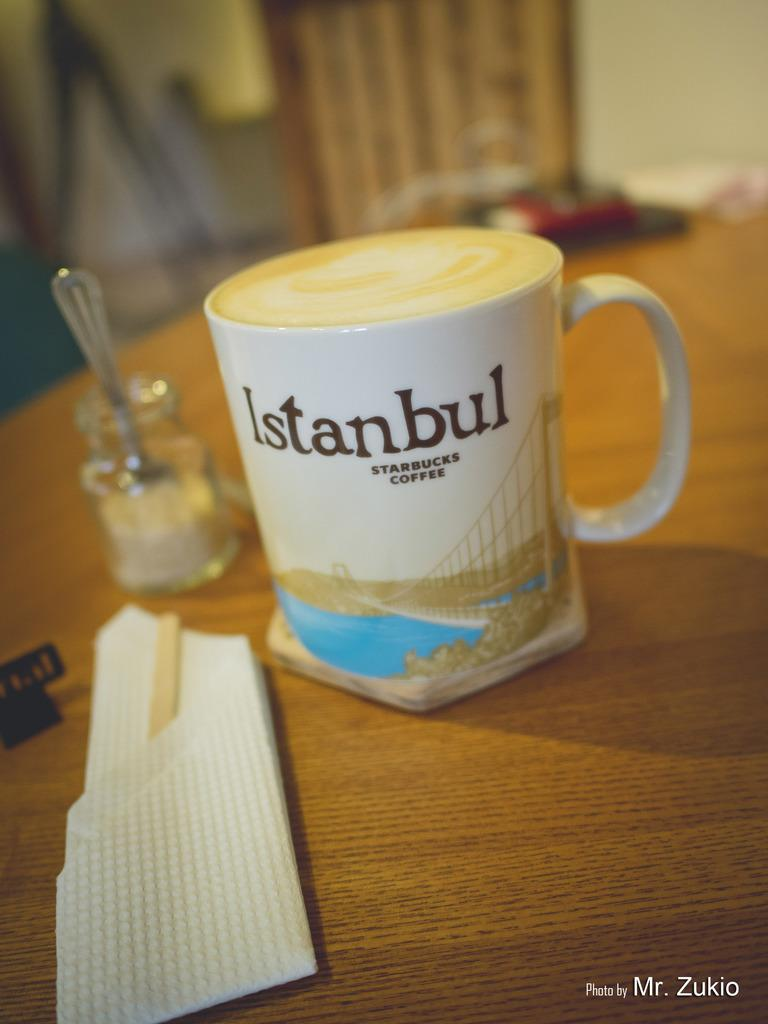<image>
Write a terse but informative summary of the picture. A full cup of latte in a mug that says Istanbul Starbucks. 